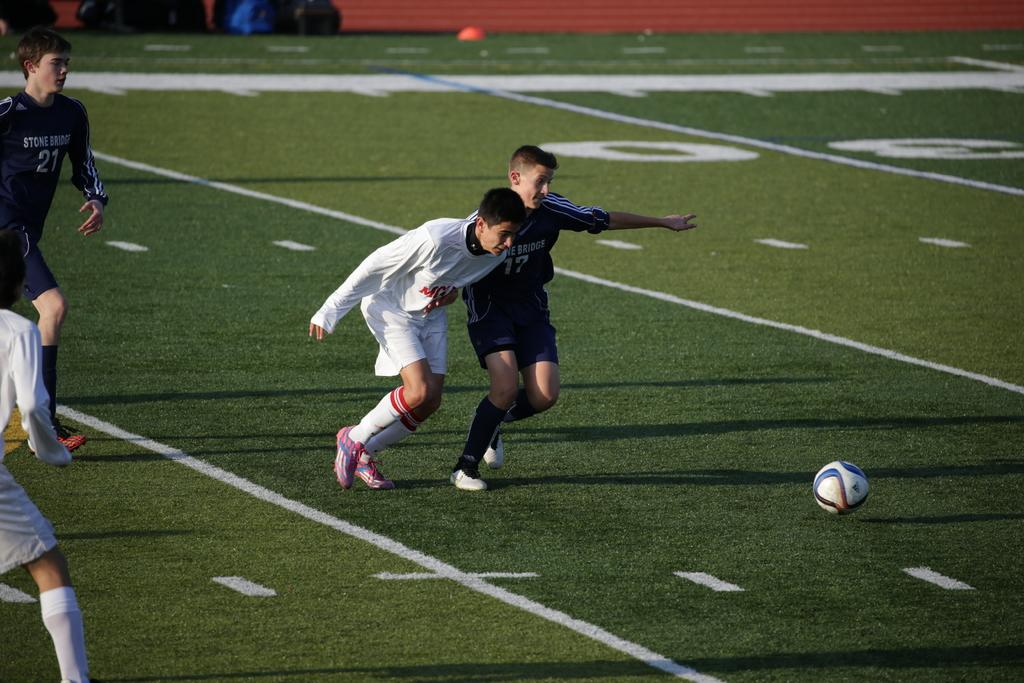<image>
Create a compact narrative representing the image presented. soccer players wearing a blue jersey that says Stone Bridge 